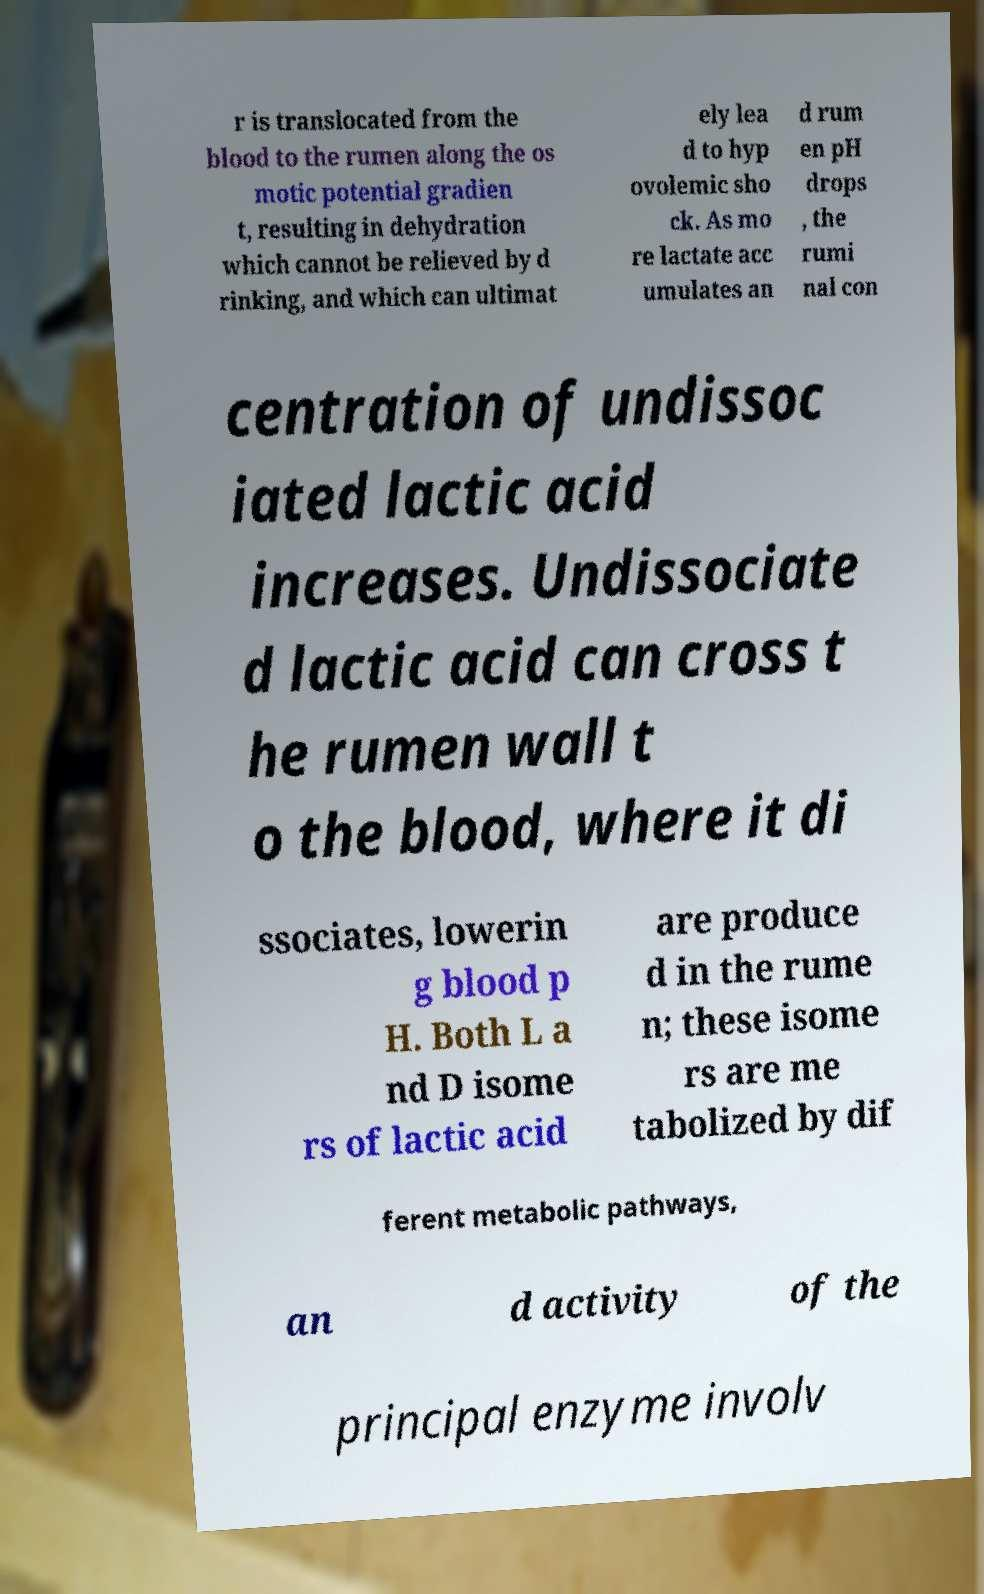Please identify and transcribe the text found in this image. r is translocated from the blood to the rumen along the os motic potential gradien t, resulting in dehydration which cannot be relieved by d rinking, and which can ultimat ely lea d to hyp ovolemic sho ck. As mo re lactate acc umulates an d rum en pH drops , the rumi nal con centration of undissoc iated lactic acid increases. Undissociate d lactic acid can cross t he rumen wall t o the blood, where it di ssociates, lowerin g blood p H. Both L a nd D isome rs of lactic acid are produce d in the rume n; these isome rs are me tabolized by dif ferent metabolic pathways, an d activity of the principal enzyme involv 